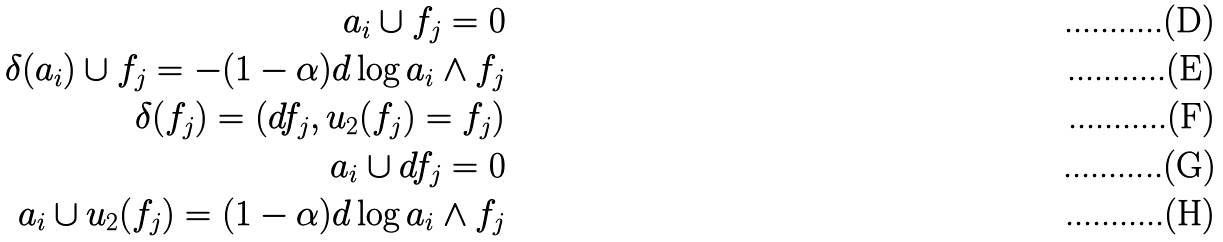Convert formula to latex. <formula><loc_0><loc_0><loc_500><loc_500>a _ { i } \cup f _ { j } = 0 \\ \delta ( a _ { i } ) \cup f _ { j } = - ( 1 - \alpha ) d \log a _ { i } \wedge f _ { j } \\ \delta ( f _ { j } ) = ( d f _ { j } , u _ { 2 } ( f _ { j } ) = f _ { j } ) \\ a _ { i } \cup d f _ { j } = 0 \\ a _ { i } \cup u _ { 2 } ( f _ { j } ) = ( 1 - \alpha ) d \log a _ { i } \wedge f _ { j }</formula> 